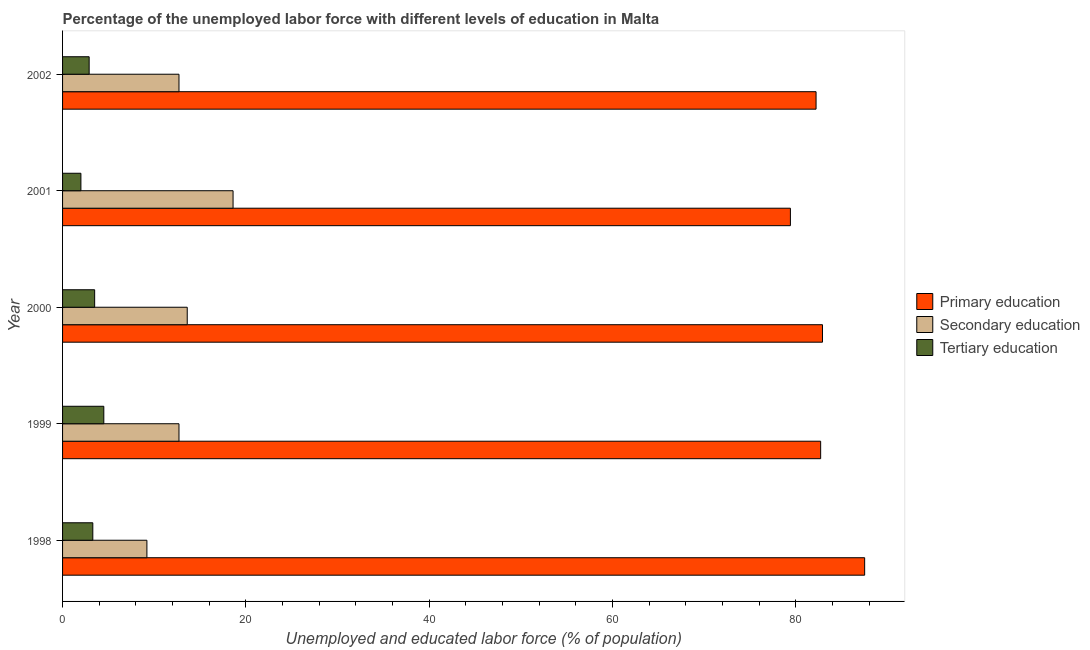How many groups of bars are there?
Keep it short and to the point. 5. Are the number of bars per tick equal to the number of legend labels?
Your answer should be very brief. Yes. Are the number of bars on each tick of the Y-axis equal?
Provide a short and direct response. Yes. What is the label of the 4th group of bars from the top?
Give a very brief answer. 1999. What is the percentage of labor force who received primary education in 2002?
Your response must be concise. 82.2. Across all years, what is the maximum percentage of labor force who received secondary education?
Provide a short and direct response. 18.6. In which year was the percentage of labor force who received primary education minimum?
Offer a very short reply. 2001. What is the total percentage of labor force who received tertiary education in the graph?
Provide a short and direct response. 16.2. What is the difference between the percentage of labor force who received primary education in 1999 and the percentage of labor force who received tertiary education in 2000?
Provide a short and direct response. 79.2. What is the average percentage of labor force who received primary education per year?
Offer a terse response. 82.94. In the year 1999, what is the difference between the percentage of labor force who received secondary education and percentage of labor force who received tertiary education?
Ensure brevity in your answer.  8.2. In how many years, is the percentage of labor force who received secondary education greater than 52 %?
Offer a very short reply. 0. What is the ratio of the percentage of labor force who received secondary education in 1998 to that in 1999?
Your response must be concise. 0.72. Is the percentage of labor force who received tertiary education in 2000 less than that in 2002?
Make the answer very short. No. What is the difference between the highest and the second highest percentage of labor force who received secondary education?
Offer a very short reply. 5. What is the difference between the highest and the lowest percentage of labor force who received primary education?
Ensure brevity in your answer.  8.1. What does the 2nd bar from the top in 1998 represents?
Provide a succinct answer. Secondary education. What does the 1st bar from the bottom in 2001 represents?
Ensure brevity in your answer.  Primary education. Is it the case that in every year, the sum of the percentage of labor force who received primary education and percentage of labor force who received secondary education is greater than the percentage of labor force who received tertiary education?
Your answer should be very brief. Yes. Are all the bars in the graph horizontal?
Make the answer very short. Yes. What is the difference between two consecutive major ticks on the X-axis?
Your response must be concise. 20. Does the graph contain any zero values?
Make the answer very short. No. What is the title of the graph?
Your answer should be very brief. Percentage of the unemployed labor force with different levels of education in Malta. What is the label or title of the X-axis?
Keep it short and to the point. Unemployed and educated labor force (% of population). What is the Unemployed and educated labor force (% of population) of Primary education in 1998?
Your response must be concise. 87.5. What is the Unemployed and educated labor force (% of population) in Secondary education in 1998?
Make the answer very short. 9.2. What is the Unemployed and educated labor force (% of population) of Tertiary education in 1998?
Your answer should be very brief. 3.3. What is the Unemployed and educated labor force (% of population) in Primary education in 1999?
Keep it short and to the point. 82.7. What is the Unemployed and educated labor force (% of population) in Secondary education in 1999?
Ensure brevity in your answer.  12.7. What is the Unemployed and educated labor force (% of population) in Primary education in 2000?
Ensure brevity in your answer.  82.9. What is the Unemployed and educated labor force (% of population) in Secondary education in 2000?
Your answer should be compact. 13.6. What is the Unemployed and educated labor force (% of population) in Primary education in 2001?
Your response must be concise. 79.4. What is the Unemployed and educated labor force (% of population) of Secondary education in 2001?
Ensure brevity in your answer.  18.6. What is the Unemployed and educated labor force (% of population) of Tertiary education in 2001?
Give a very brief answer. 2. What is the Unemployed and educated labor force (% of population) in Primary education in 2002?
Provide a succinct answer. 82.2. What is the Unemployed and educated labor force (% of population) in Secondary education in 2002?
Offer a very short reply. 12.7. What is the Unemployed and educated labor force (% of population) of Tertiary education in 2002?
Offer a very short reply. 2.9. Across all years, what is the maximum Unemployed and educated labor force (% of population) of Primary education?
Offer a terse response. 87.5. Across all years, what is the maximum Unemployed and educated labor force (% of population) in Secondary education?
Your answer should be very brief. 18.6. Across all years, what is the minimum Unemployed and educated labor force (% of population) of Primary education?
Your response must be concise. 79.4. Across all years, what is the minimum Unemployed and educated labor force (% of population) of Secondary education?
Offer a terse response. 9.2. Across all years, what is the minimum Unemployed and educated labor force (% of population) of Tertiary education?
Ensure brevity in your answer.  2. What is the total Unemployed and educated labor force (% of population) in Primary education in the graph?
Your answer should be compact. 414.7. What is the total Unemployed and educated labor force (% of population) of Secondary education in the graph?
Your response must be concise. 66.8. What is the total Unemployed and educated labor force (% of population) in Tertiary education in the graph?
Your answer should be very brief. 16.2. What is the difference between the Unemployed and educated labor force (% of population) of Tertiary education in 1998 and that in 1999?
Your answer should be compact. -1.2. What is the difference between the Unemployed and educated labor force (% of population) of Secondary education in 1998 and that in 2000?
Your answer should be very brief. -4.4. What is the difference between the Unemployed and educated labor force (% of population) of Primary education in 1998 and that in 2001?
Offer a very short reply. 8.1. What is the difference between the Unemployed and educated labor force (% of population) of Secondary education in 1998 and that in 2001?
Your response must be concise. -9.4. What is the difference between the Unemployed and educated labor force (% of population) in Primary education in 1998 and that in 2002?
Your response must be concise. 5.3. What is the difference between the Unemployed and educated labor force (% of population) in Secondary education in 1998 and that in 2002?
Ensure brevity in your answer.  -3.5. What is the difference between the Unemployed and educated labor force (% of population) in Tertiary education in 1999 and that in 2000?
Ensure brevity in your answer.  1. What is the difference between the Unemployed and educated labor force (% of population) of Secondary education in 1999 and that in 2001?
Your response must be concise. -5.9. What is the difference between the Unemployed and educated labor force (% of population) of Primary education in 1999 and that in 2002?
Provide a succinct answer. 0.5. What is the difference between the Unemployed and educated labor force (% of population) in Tertiary education in 1999 and that in 2002?
Give a very brief answer. 1.6. What is the difference between the Unemployed and educated labor force (% of population) of Tertiary education in 2000 and that in 2002?
Offer a very short reply. 0.6. What is the difference between the Unemployed and educated labor force (% of population) in Secondary education in 2001 and that in 2002?
Your response must be concise. 5.9. What is the difference between the Unemployed and educated labor force (% of population) of Primary education in 1998 and the Unemployed and educated labor force (% of population) of Secondary education in 1999?
Your answer should be very brief. 74.8. What is the difference between the Unemployed and educated labor force (% of population) in Primary education in 1998 and the Unemployed and educated labor force (% of population) in Tertiary education in 1999?
Provide a short and direct response. 83. What is the difference between the Unemployed and educated labor force (% of population) in Secondary education in 1998 and the Unemployed and educated labor force (% of population) in Tertiary education in 1999?
Provide a succinct answer. 4.7. What is the difference between the Unemployed and educated labor force (% of population) in Primary education in 1998 and the Unemployed and educated labor force (% of population) in Secondary education in 2000?
Keep it short and to the point. 73.9. What is the difference between the Unemployed and educated labor force (% of population) in Primary education in 1998 and the Unemployed and educated labor force (% of population) in Secondary education in 2001?
Provide a short and direct response. 68.9. What is the difference between the Unemployed and educated labor force (% of population) in Primary education in 1998 and the Unemployed and educated labor force (% of population) in Tertiary education in 2001?
Keep it short and to the point. 85.5. What is the difference between the Unemployed and educated labor force (% of population) in Primary education in 1998 and the Unemployed and educated labor force (% of population) in Secondary education in 2002?
Offer a terse response. 74.8. What is the difference between the Unemployed and educated labor force (% of population) of Primary education in 1998 and the Unemployed and educated labor force (% of population) of Tertiary education in 2002?
Offer a very short reply. 84.6. What is the difference between the Unemployed and educated labor force (% of population) of Secondary education in 1998 and the Unemployed and educated labor force (% of population) of Tertiary education in 2002?
Offer a terse response. 6.3. What is the difference between the Unemployed and educated labor force (% of population) in Primary education in 1999 and the Unemployed and educated labor force (% of population) in Secondary education in 2000?
Your answer should be compact. 69.1. What is the difference between the Unemployed and educated labor force (% of population) in Primary education in 1999 and the Unemployed and educated labor force (% of population) in Tertiary education in 2000?
Keep it short and to the point. 79.2. What is the difference between the Unemployed and educated labor force (% of population) of Secondary education in 1999 and the Unemployed and educated labor force (% of population) of Tertiary education in 2000?
Make the answer very short. 9.2. What is the difference between the Unemployed and educated labor force (% of population) in Primary education in 1999 and the Unemployed and educated labor force (% of population) in Secondary education in 2001?
Your answer should be compact. 64.1. What is the difference between the Unemployed and educated labor force (% of population) of Primary education in 1999 and the Unemployed and educated labor force (% of population) of Tertiary education in 2001?
Your answer should be compact. 80.7. What is the difference between the Unemployed and educated labor force (% of population) in Primary education in 1999 and the Unemployed and educated labor force (% of population) in Tertiary education in 2002?
Ensure brevity in your answer.  79.8. What is the difference between the Unemployed and educated labor force (% of population) in Primary education in 2000 and the Unemployed and educated labor force (% of population) in Secondary education in 2001?
Your answer should be compact. 64.3. What is the difference between the Unemployed and educated labor force (% of population) of Primary education in 2000 and the Unemployed and educated labor force (% of population) of Tertiary education in 2001?
Your answer should be very brief. 80.9. What is the difference between the Unemployed and educated labor force (% of population) in Secondary education in 2000 and the Unemployed and educated labor force (% of population) in Tertiary education in 2001?
Provide a succinct answer. 11.6. What is the difference between the Unemployed and educated labor force (% of population) in Primary education in 2000 and the Unemployed and educated labor force (% of population) in Secondary education in 2002?
Give a very brief answer. 70.2. What is the difference between the Unemployed and educated labor force (% of population) in Secondary education in 2000 and the Unemployed and educated labor force (% of population) in Tertiary education in 2002?
Offer a terse response. 10.7. What is the difference between the Unemployed and educated labor force (% of population) of Primary education in 2001 and the Unemployed and educated labor force (% of population) of Secondary education in 2002?
Your answer should be very brief. 66.7. What is the difference between the Unemployed and educated labor force (% of population) in Primary education in 2001 and the Unemployed and educated labor force (% of population) in Tertiary education in 2002?
Your response must be concise. 76.5. What is the difference between the Unemployed and educated labor force (% of population) in Secondary education in 2001 and the Unemployed and educated labor force (% of population) in Tertiary education in 2002?
Your answer should be compact. 15.7. What is the average Unemployed and educated labor force (% of population) of Primary education per year?
Provide a short and direct response. 82.94. What is the average Unemployed and educated labor force (% of population) in Secondary education per year?
Your response must be concise. 13.36. What is the average Unemployed and educated labor force (% of population) in Tertiary education per year?
Give a very brief answer. 3.24. In the year 1998, what is the difference between the Unemployed and educated labor force (% of population) in Primary education and Unemployed and educated labor force (% of population) in Secondary education?
Make the answer very short. 78.3. In the year 1998, what is the difference between the Unemployed and educated labor force (% of population) of Primary education and Unemployed and educated labor force (% of population) of Tertiary education?
Provide a short and direct response. 84.2. In the year 1998, what is the difference between the Unemployed and educated labor force (% of population) in Secondary education and Unemployed and educated labor force (% of population) in Tertiary education?
Keep it short and to the point. 5.9. In the year 1999, what is the difference between the Unemployed and educated labor force (% of population) in Primary education and Unemployed and educated labor force (% of population) in Secondary education?
Your answer should be very brief. 70. In the year 1999, what is the difference between the Unemployed and educated labor force (% of population) in Primary education and Unemployed and educated labor force (% of population) in Tertiary education?
Offer a very short reply. 78.2. In the year 2000, what is the difference between the Unemployed and educated labor force (% of population) in Primary education and Unemployed and educated labor force (% of population) in Secondary education?
Provide a short and direct response. 69.3. In the year 2000, what is the difference between the Unemployed and educated labor force (% of population) in Primary education and Unemployed and educated labor force (% of population) in Tertiary education?
Your answer should be very brief. 79.4. In the year 2001, what is the difference between the Unemployed and educated labor force (% of population) of Primary education and Unemployed and educated labor force (% of population) of Secondary education?
Offer a very short reply. 60.8. In the year 2001, what is the difference between the Unemployed and educated labor force (% of population) in Primary education and Unemployed and educated labor force (% of population) in Tertiary education?
Provide a short and direct response. 77.4. In the year 2001, what is the difference between the Unemployed and educated labor force (% of population) of Secondary education and Unemployed and educated labor force (% of population) of Tertiary education?
Provide a succinct answer. 16.6. In the year 2002, what is the difference between the Unemployed and educated labor force (% of population) of Primary education and Unemployed and educated labor force (% of population) of Secondary education?
Offer a very short reply. 69.5. In the year 2002, what is the difference between the Unemployed and educated labor force (% of population) in Primary education and Unemployed and educated labor force (% of population) in Tertiary education?
Give a very brief answer. 79.3. What is the ratio of the Unemployed and educated labor force (% of population) in Primary education in 1998 to that in 1999?
Your answer should be very brief. 1.06. What is the ratio of the Unemployed and educated labor force (% of population) of Secondary education in 1998 to that in 1999?
Offer a terse response. 0.72. What is the ratio of the Unemployed and educated labor force (% of population) of Tertiary education in 1998 to that in 1999?
Offer a very short reply. 0.73. What is the ratio of the Unemployed and educated labor force (% of population) of Primary education in 1998 to that in 2000?
Provide a succinct answer. 1.06. What is the ratio of the Unemployed and educated labor force (% of population) of Secondary education in 1998 to that in 2000?
Your response must be concise. 0.68. What is the ratio of the Unemployed and educated labor force (% of population) of Tertiary education in 1998 to that in 2000?
Keep it short and to the point. 0.94. What is the ratio of the Unemployed and educated labor force (% of population) of Primary education in 1998 to that in 2001?
Provide a succinct answer. 1.1. What is the ratio of the Unemployed and educated labor force (% of population) of Secondary education in 1998 to that in 2001?
Ensure brevity in your answer.  0.49. What is the ratio of the Unemployed and educated labor force (% of population) in Tertiary education in 1998 to that in 2001?
Make the answer very short. 1.65. What is the ratio of the Unemployed and educated labor force (% of population) in Primary education in 1998 to that in 2002?
Your answer should be compact. 1.06. What is the ratio of the Unemployed and educated labor force (% of population) of Secondary education in 1998 to that in 2002?
Your answer should be compact. 0.72. What is the ratio of the Unemployed and educated labor force (% of population) in Tertiary education in 1998 to that in 2002?
Ensure brevity in your answer.  1.14. What is the ratio of the Unemployed and educated labor force (% of population) of Primary education in 1999 to that in 2000?
Keep it short and to the point. 1. What is the ratio of the Unemployed and educated labor force (% of population) in Secondary education in 1999 to that in 2000?
Make the answer very short. 0.93. What is the ratio of the Unemployed and educated labor force (% of population) in Primary education in 1999 to that in 2001?
Offer a very short reply. 1.04. What is the ratio of the Unemployed and educated labor force (% of population) in Secondary education in 1999 to that in 2001?
Provide a short and direct response. 0.68. What is the ratio of the Unemployed and educated labor force (% of population) in Tertiary education in 1999 to that in 2001?
Offer a terse response. 2.25. What is the ratio of the Unemployed and educated labor force (% of population) of Tertiary education in 1999 to that in 2002?
Keep it short and to the point. 1.55. What is the ratio of the Unemployed and educated labor force (% of population) in Primary education in 2000 to that in 2001?
Your response must be concise. 1.04. What is the ratio of the Unemployed and educated labor force (% of population) in Secondary education in 2000 to that in 2001?
Your response must be concise. 0.73. What is the ratio of the Unemployed and educated labor force (% of population) in Tertiary education in 2000 to that in 2001?
Make the answer very short. 1.75. What is the ratio of the Unemployed and educated labor force (% of population) in Primary education in 2000 to that in 2002?
Provide a short and direct response. 1.01. What is the ratio of the Unemployed and educated labor force (% of population) in Secondary education in 2000 to that in 2002?
Ensure brevity in your answer.  1.07. What is the ratio of the Unemployed and educated labor force (% of population) of Tertiary education in 2000 to that in 2002?
Offer a very short reply. 1.21. What is the ratio of the Unemployed and educated labor force (% of population) in Primary education in 2001 to that in 2002?
Your answer should be compact. 0.97. What is the ratio of the Unemployed and educated labor force (% of population) of Secondary education in 2001 to that in 2002?
Offer a terse response. 1.46. What is the ratio of the Unemployed and educated labor force (% of population) in Tertiary education in 2001 to that in 2002?
Your response must be concise. 0.69. What is the difference between the highest and the second highest Unemployed and educated labor force (% of population) of Secondary education?
Offer a terse response. 5. 